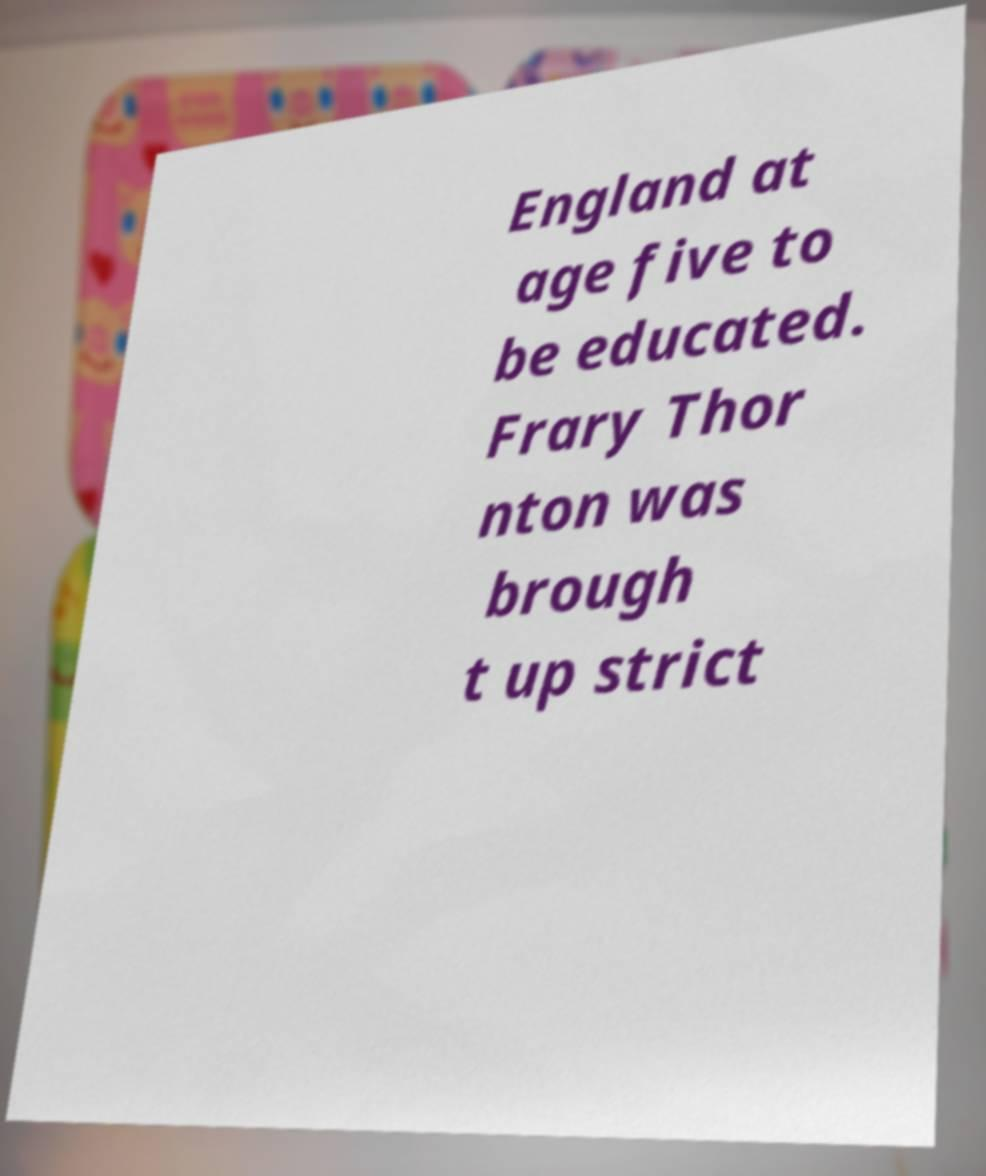There's text embedded in this image that I need extracted. Can you transcribe it verbatim? England at age five to be educated. Frary Thor nton was brough t up strict 